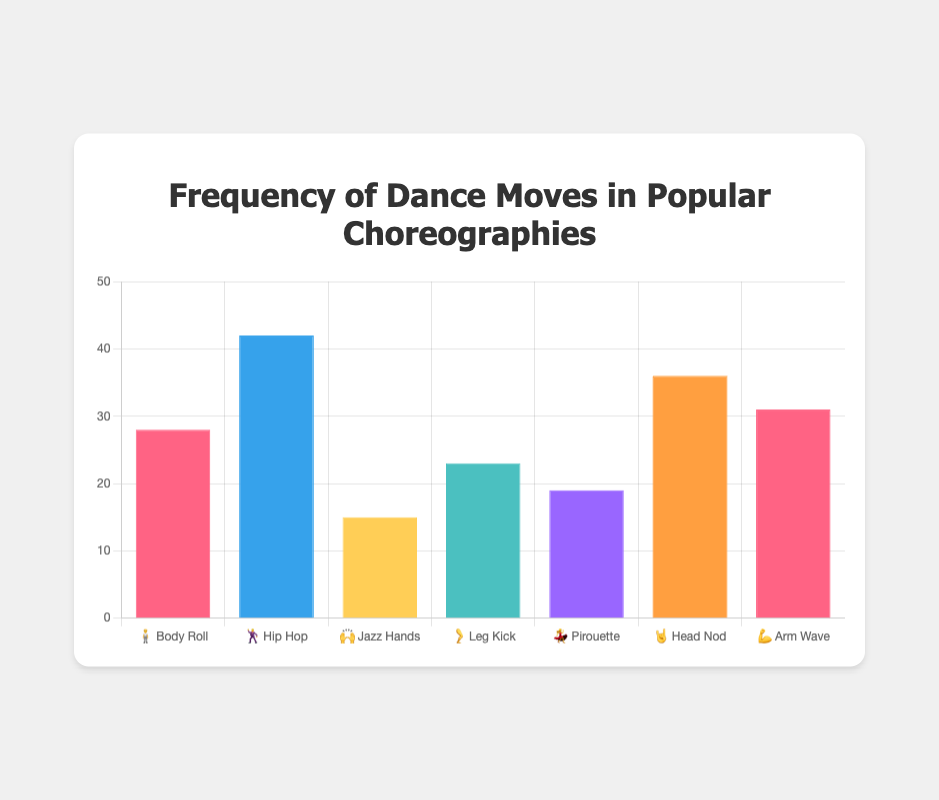Which dance move has the highest frequency? Look at the bar with the highest value. The one labeled "🕺 Hip Hop" has the highest frequency.
Answer: Hip Hop What is the frequency of the 🤘 Head Nod move? Locate the bar labeled 🤘 Head Nod and read its height on the y-axis. It corresponds to a frequency of 36.
Answer: 36 Which dance move has the lowest frequency? Identify the bar with the lowest value by comparing all the bar heights. The one labeled "🙌 Jazz Hands" has the lowest frequency.
Answer: Jazz Hands How many dance moves have frequencies greater than 30? Count the bars with heights above the 30 mark on the y-axis: 🕺 Hip Hop, 🤘 Head Nod, and 💪 Arm Wave.
Answer: 3 What's the sum of the frequencies of 🧍 Body Roll and 🦵 Leg Kick? Add the frequencies of 🧍 Body Roll (28) and 🦵 Leg Kick (23). Calculation: 28 + 23 = 51
Answer: 51 What's the average frequency of all the dance moves? Sum all the frequencies (28 + 42 + 15 + 23 + 19 + 36 + 31) and divide by the total number of moves (7). Calculation: (28 + 42 + 15 + 23 + 19 + 36 + 31) / 7 = 27.71
Answer: 27.71 Which dance move is more frequent: 🦵 Leg Kick or 💃 Pirouette? Compare the heights of the bars labeled 🦵 Leg Kick (23) and 💃 Pirouette (19).
Answer: Leg Kick By how much is the frequency of 💪 Arm Wave greater than that of 🙌 Jazz Hands? Subtract the frequency of 🙌 Jazz Hands (15) from the frequency of 💪 Arm Wave (31). Calculation: 31 - 15 = 16
Answer: 16 Arrange the dance moves in descending order of frequency. Rank the moves from highest to lowest frequency: 🕺 Hip Hop (42), 🤘 Head Nod (36), 💪 Arm Wave (31), 🧍 Body Roll (28), 🦵 Leg Kick (23), 💃 Pirouette (19), 🙌 Jazz Hands (15).
Answer: Hip Hop, Head Nod, Arm Wave, Body Roll, Leg Kick, Pirouette, Jazz Hands What is the difference in frequency between the most and least common dance moves? Subtract the lowest frequency (🙌 Jazz Hands: 15) from the highest frequency (🕺 Hip Hop: 42). Calculation: 42 - 15 = 27
Answer: 27 